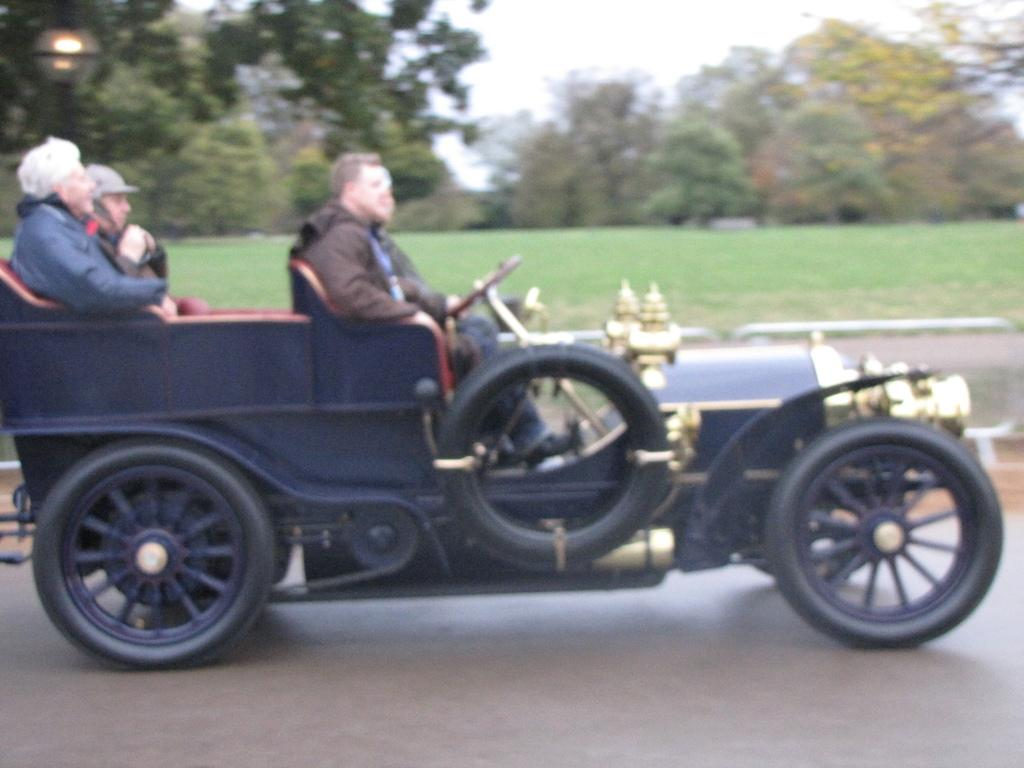What are the persons in the image doing? The persons in the image are sitting on a vehicle. What can be seen in the background of the image? There is a ground, trees, a light, and the sky visible in the background of the image. What type of wristwatch is the judge wearing in the image? There is no judge or wristwatch present in the image. How can the persons in the image increase their speed while sitting on the vehicle? The image does not provide information about how to increase the speed of the vehicle, and the persons are already sitting on it. 